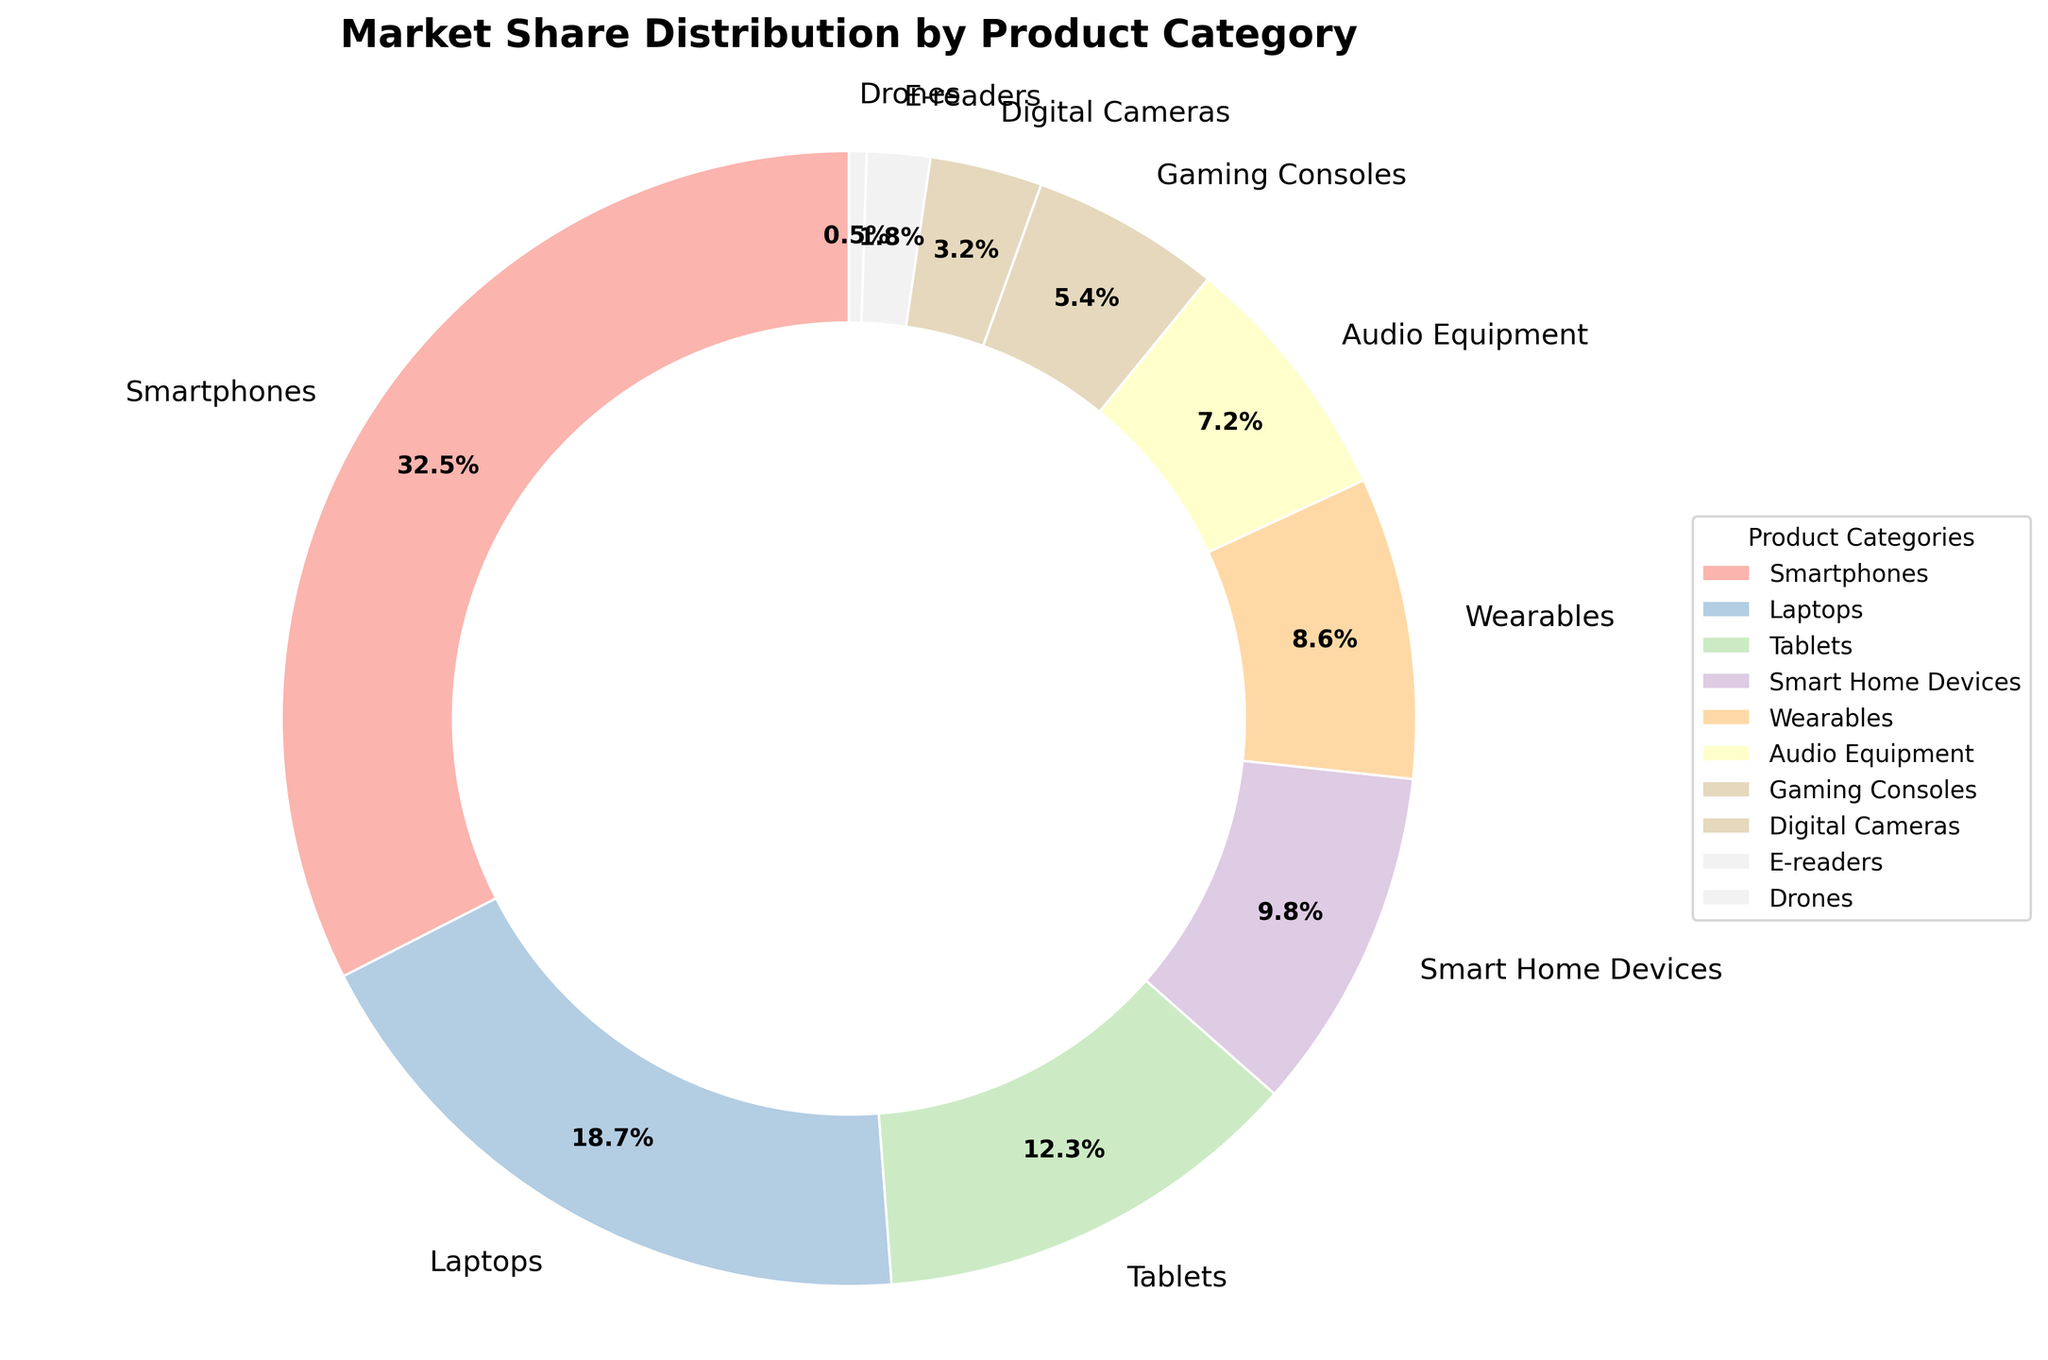What's the most dominant product category in terms of market share? By looking at the figure, the category with the largest segment, labeled with the highest percentage, represents the most dominant product category.
Answer: Smartphones Which two product categories together make up more than 50% of the market share? Adding the percentages of all product categories shown in the figure, the sum for Smartphones (32.5%) and Laptops (18.7%) is the highest and exceeds 50%.
Answer: Smartphones and Laptops Which category has a larger market share: Smart Home Devices or Tablets? By comparing the percentages directly from the figure, Tablets have 12.3% while Smart Home Devices have 9.8%.
Answer: Tablets How many product categories have a market share less than 5%? Identifying all segments with percentages less than 5% in the figure, we find Digital Cameras (3.2%), E-readers (1.8%), and Drones (0.5%).
Answer: 3 Do Wearables have a higher market share than Audio Equipment? By directly comparing the percentages from the figure, Wearables have 8.6% while Audio Equipment has 7.2%.
Answer: Yes What is the total market share of the bottom five categories? By summing up the percentages of the five smallest segments (Audio Equipment - 7.2%, Gaming Consoles - 5.4%, Digital Cameras - 3.2%, E-readers - 1.8%, Drones - 0.5%), the combined market share is (7.2 + 5.4 + 3.2 + 1.8 + 0.5) = 18.1%.
Answer: 18.1% Which product categories have less market share than Wearables but more than Gaming Consoles? From the figure, we identify that with Wearables at 8.6% and Gaming Consoles at 5.4%, the categories in between are Smart Home Devices (9.8%) and Audio Equipment (7.2%).
Answer: Smart Home Devices and Audio Equipment What percentage more is the market share of Tablets compared to Gaming Consoles? Subtracting the percentage of Gaming Consoles (5.4%) from Tablets (12.3%) gives the difference, which is 12.3 - 5.4 = 6.9. To find the relative difference, (6.9/5.4) * 100 ≈ 127.78%.
Answer: 127.78% Which segment appears visually smallest in the figure? The segment with the smallest percentage label, which appears as the smallest wedge in the figure, is Drones with 0.5%.
Answer: Drones 